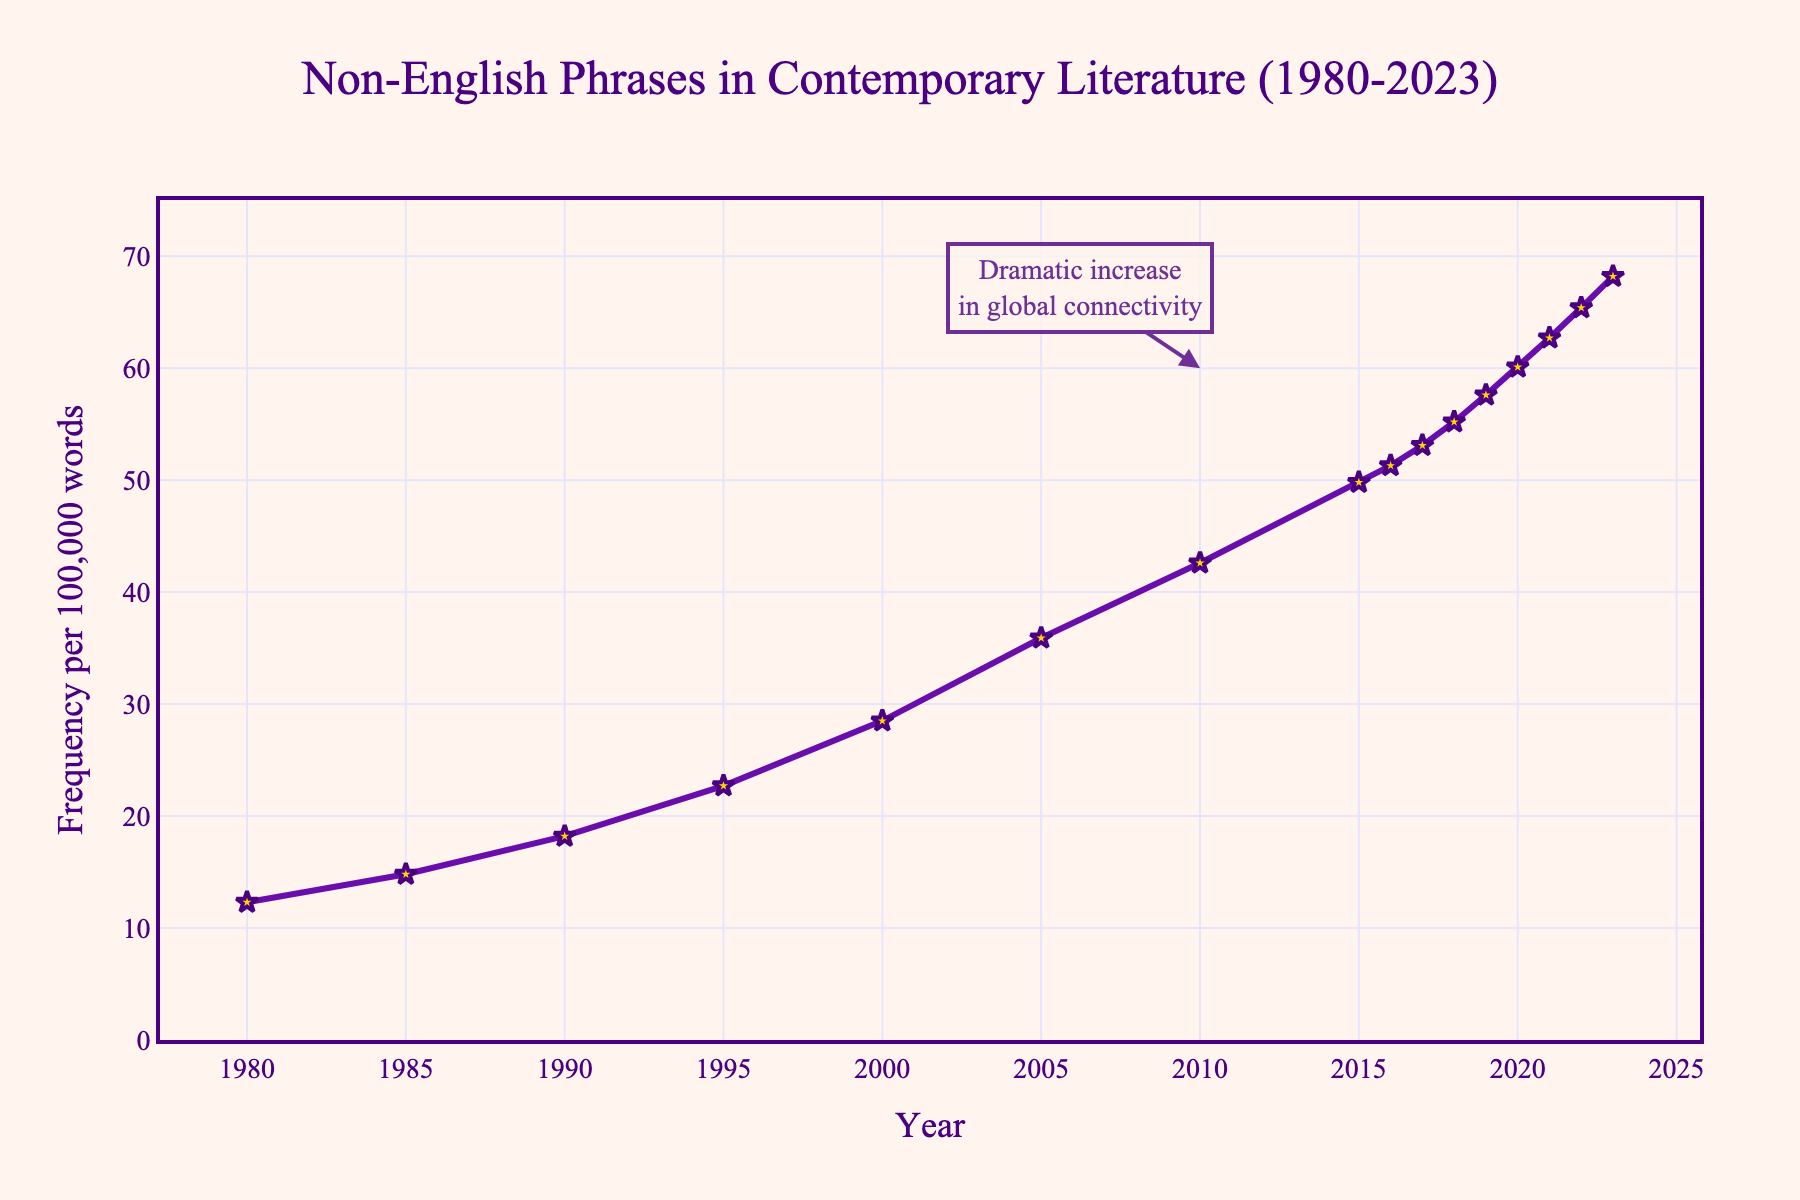What year shows the highest frequency of non-English phrases? To determine the year with the highest frequency, look for the highest point on the line chart. The y-axis value of the highest point corresponds to the highest frequency, and the x-axis indicates the year.
Answer: 2023 How much did the frequency increase from 1980 to 2000? Find the y-axis values for both 1980 and 2000. Subtract the 1980 value from the 2000 value: 28.5 - 12.3.
Answer: 16.2 Which year experienced the most significant increase in frequency compared to the previous year? Compare the difference in y-axis values year over year. The year with the largest increase is between 2005 and 2010 (42.6 - 35.9).
Answer: 2010 What is the average frequency of non-English phrases from 2018 to 2023? Add the frequencies for each year from 2018 to 2023: (55.2 + 57.6 + 60.1 + 62.7 + 65.4 + 68.2) and divide by the number of years (6).
Answer: 61.533 Describe the trend of non-English phrases in literature from 1980 to 2023. The trend shows a consistent increase, with the frequency rising each year from 1980 to 2023.
Answer: Increasing consistently How long did it take for the frequency to double compared to 1980? Determine the year where the frequency is approximately double 12.3. The closest year is 2005 with 35.9, which is almost triple 12.3.
Answer: 25 years What can you infer about global connectivity from the annotation in the plot? The annotation indicates a dramatic increase in global connectivity around 2010, suggesting that this connectivity might have influenced the rising frequency of non-English phrases.
Answer: Increased connectivity influenced frequency Which years show above 50 frequency? Identify years with a y-axis value above 50: 2016, 2017, 2018, 2019, 2020, 2021, 2022, and 2023.
Answer: 2016-2023 What was the slope of the increase in frequency from 2010 to 2015? Calculate the difference in frequency (49.8 - 42.6) and divide by the number of years (5): (49.8 - 42.6)/5.
Answer: 1.44 By what percentage did the frequency increase from 2016 to 2023? Calculate the percentage increase: ((68.2 - 51.3) / 51.3) * 100%.
Answer: 33.04% 